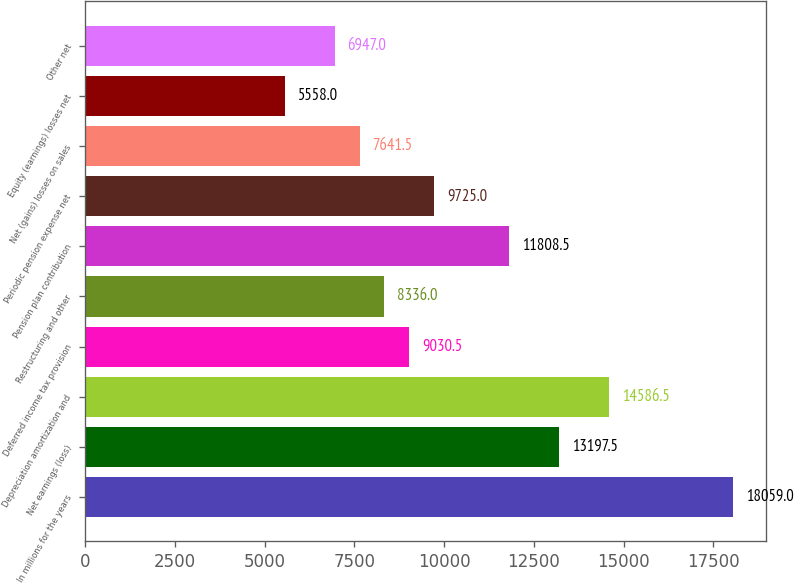<chart> <loc_0><loc_0><loc_500><loc_500><bar_chart><fcel>In millions for the years<fcel>Net earnings (loss)<fcel>Depreciation amortization and<fcel>Deferred income tax provision<fcel>Restructuring and other<fcel>Pension plan contribution<fcel>Periodic pension expense net<fcel>Net (gains) losses on sales<fcel>Equity (earnings) losses net<fcel>Other net<nl><fcel>18059<fcel>13197.5<fcel>14586.5<fcel>9030.5<fcel>8336<fcel>11808.5<fcel>9725<fcel>7641.5<fcel>5558<fcel>6947<nl></chart> 